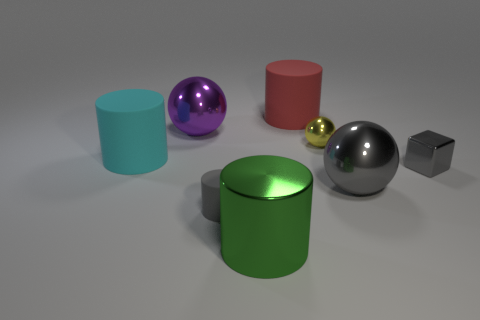Subtract all small cylinders. How many cylinders are left? 3 Subtract all red cylinders. How many cylinders are left? 3 Subtract all tiny blue rubber things. Subtract all green metal cylinders. How many objects are left? 7 Add 5 small cylinders. How many small cylinders are left? 6 Add 6 gray matte things. How many gray matte things exist? 7 Add 1 big blue matte blocks. How many objects exist? 9 Subtract 0 red cubes. How many objects are left? 8 Subtract all cubes. How many objects are left? 7 Subtract 2 cylinders. How many cylinders are left? 2 Subtract all gray cylinders. Subtract all gray blocks. How many cylinders are left? 3 